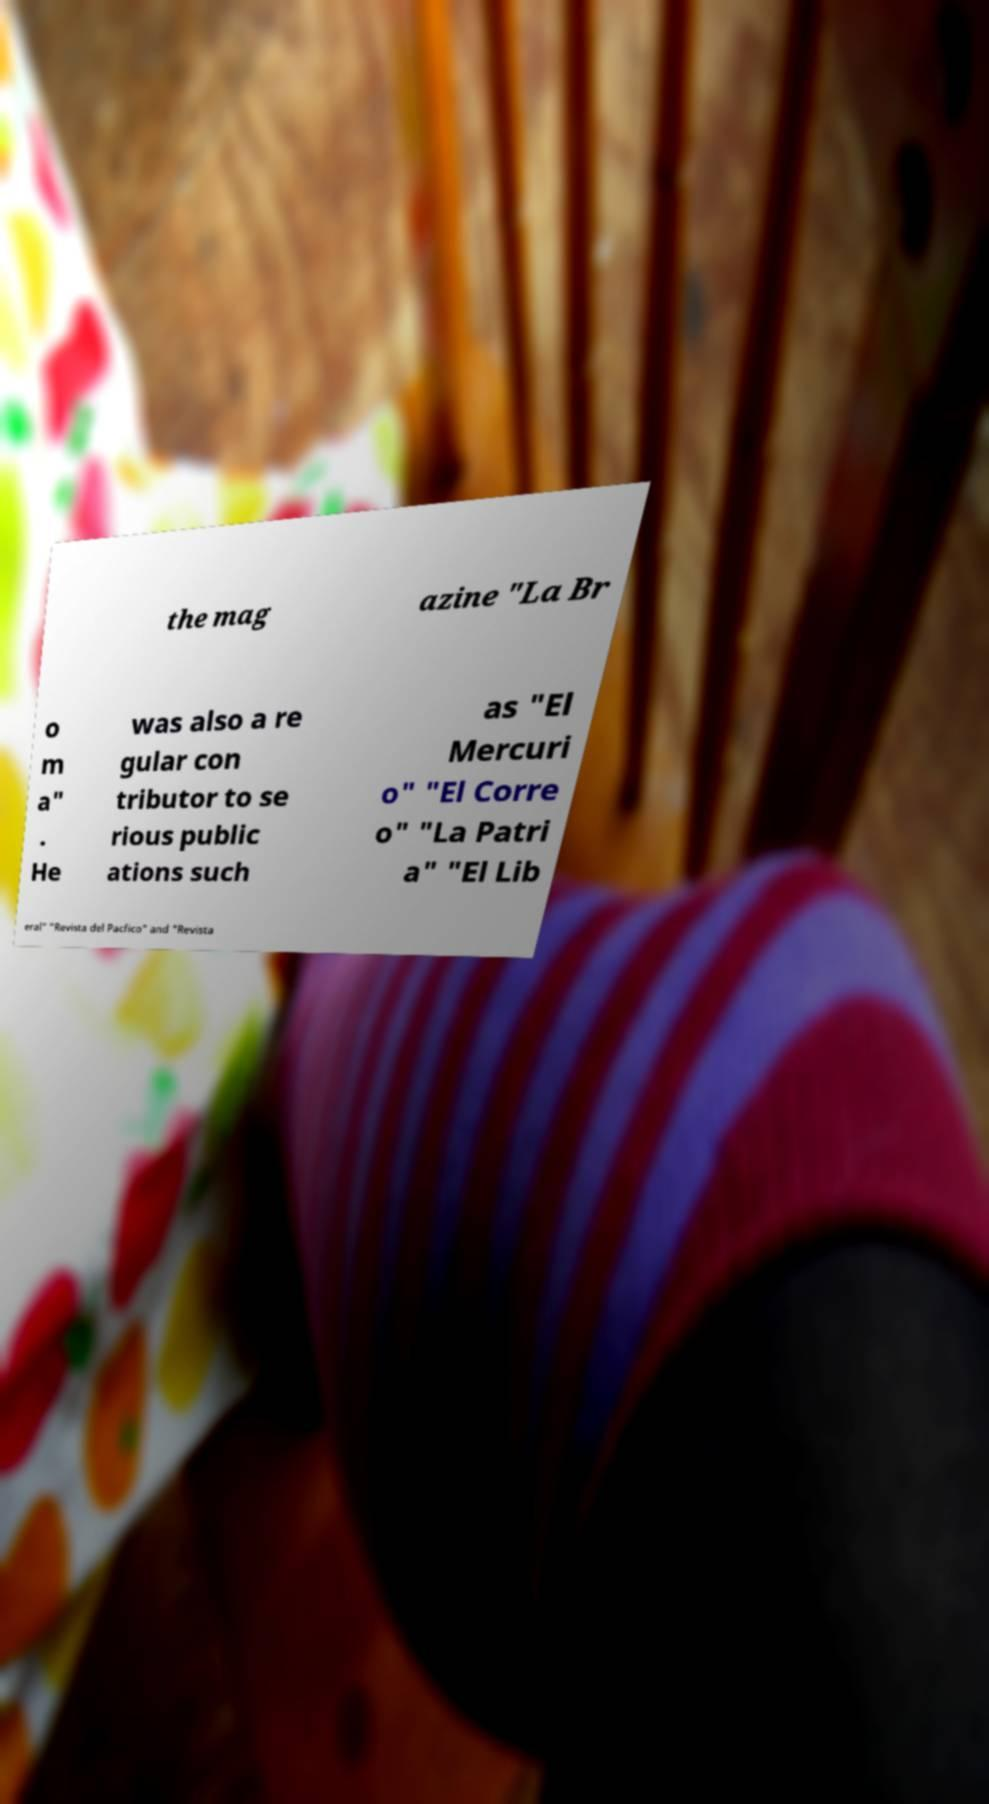I need the written content from this picture converted into text. Can you do that? the mag azine "La Br o m a" . He was also a re gular con tributor to se rious public ations such as "El Mercuri o" "El Corre o" "La Patri a" "El Lib eral" "Revista del Pacfico" and "Revista 